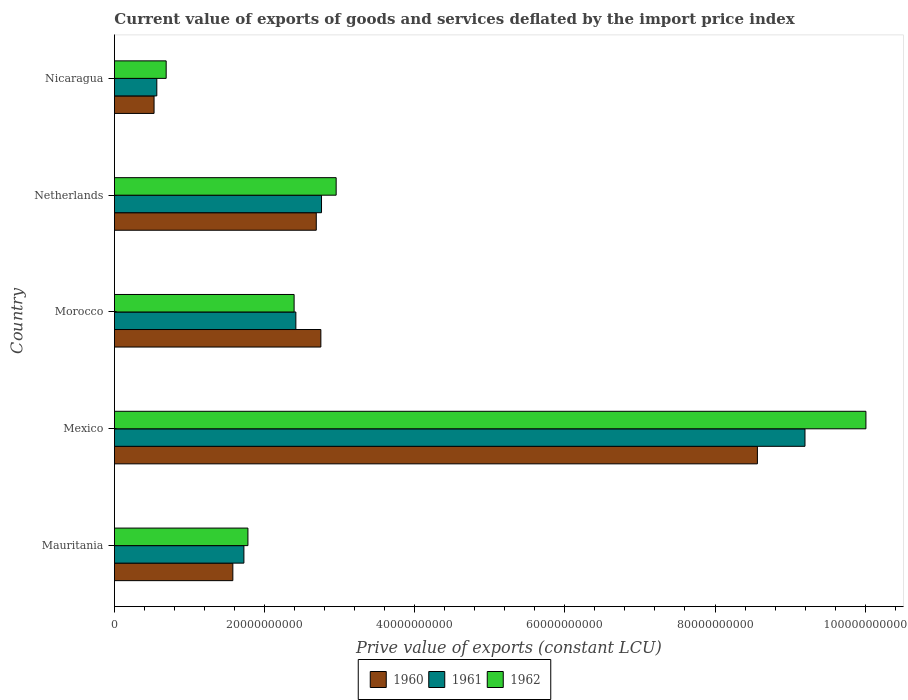Are the number of bars on each tick of the Y-axis equal?
Ensure brevity in your answer.  Yes. How many bars are there on the 2nd tick from the bottom?
Keep it short and to the point. 3. What is the label of the 5th group of bars from the top?
Ensure brevity in your answer.  Mauritania. In how many cases, is the number of bars for a given country not equal to the number of legend labels?
Give a very brief answer. 0. What is the prive value of exports in 1962 in Netherlands?
Offer a terse response. 2.95e+1. Across all countries, what is the maximum prive value of exports in 1961?
Your response must be concise. 9.20e+1. Across all countries, what is the minimum prive value of exports in 1962?
Your answer should be very brief. 6.89e+09. In which country was the prive value of exports in 1960 maximum?
Keep it short and to the point. Mexico. In which country was the prive value of exports in 1961 minimum?
Ensure brevity in your answer.  Nicaragua. What is the total prive value of exports in 1962 in the graph?
Provide a short and direct response. 1.78e+11. What is the difference between the prive value of exports in 1962 in Mexico and that in Netherlands?
Provide a succinct answer. 7.06e+1. What is the difference between the prive value of exports in 1960 in Netherlands and the prive value of exports in 1962 in Morocco?
Keep it short and to the point. 2.95e+09. What is the average prive value of exports in 1962 per country?
Give a very brief answer. 3.56e+1. What is the difference between the prive value of exports in 1960 and prive value of exports in 1961 in Netherlands?
Make the answer very short. -6.97e+08. What is the ratio of the prive value of exports in 1961 in Morocco to that in Netherlands?
Give a very brief answer. 0.88. Is the difference between the prive value of exports in 1960 in Morocco and Netherlands greater than the difference between the prive value of exports in 1961 in Morocco and Netherlands?
Ensure brevity in your answer.  Yes. What is the difference between the highest and the second highest prive value of exports in 1961?
Ensure brevity in your answer.  6.44e+1. What is the difference between the highest and the lowest prive value of exports in 1960?
Offer a very short reply. 8.04e+1. In how many countries, is the prive value of exports in 1962 greater than the average prive value of exports in 1962 taken over all countries?
Your answer should be very brief. 1. Is the sum of the prive value of exports in 1962 in Mauritania and Morocco greater than the maximum prive value of exports in 1961 across all countries?
Your answer should be very brief. No. What does the 1st bar from the bottom in Nicaragua represents?
Ensure brevity in your answer.  1960. Where does the legend appear in the graph?
Offer a terse response. Bottom center. How many legend labels are there?
Offer a terse response. 3. How are the legend labels stacked?
Offer a terse response. Horizontal. What is the title of the graph?
Provide a short and direct response. Current value of exports of goods and services deflated by the import price index. What is the label or title of the X-axis?
Provide a short and direct response. Prive value of exports (constant LCU). What is the label or title of the Y-axis?
Keep it short and to the point. Country. What is the Prive value of exports (constant LCU) of 1960 in Mauritania?
Your answer should be compact. 1.58e+1. What is the Prive value of exports (constant LCU) in 1961 in Mauritania?
Give a very brief answer. 1.72e+1. What is the Prive value of exports (constant LCU) in 1962 in Mauritania?
Your answer should be very brief. 1.78e+1. What is the Prive value of exports (constant LCU) of 1960 in Mexico?
Give a very brief answer. 8.56e+1. What is the Prive value of exports (constant LCU) of 1961 in Mexico?
Provide a short and direct response. 9.20e+1. What is the Prive value of exports (constant LCU) in 1962 in Mexico?
Provide a short and direct response. 1.00e+11. What is the Prive value of exports (constant LCU) of 1960 in Morocco?
Your answer should be very brief. 2.75e+1. What is the Prive value of exports (constant LCU) of 1961 in Morocco?
Provide a succinct answer. 2.42e+1. What is the Prive value of exports (constant LCU) in 1962 in Morocco?
Make the answer very short. 2.39e+1. What is the Prive value of exports (constant LCU) in 1960 in Netherlands?
Your response must be concise. 2.69e+1. What is the Prive value of exports (constant LCU) in 1961 in Netherlands?
Provide a succinct answer. 2.76e+1. What is the Prive value of exports (constant LCU) of 1962 in Netherlands?
Provide a succinct answer. 2.95e+1. What is the Prive value of exports (constant LCU) of 1960 in Nicaragua?
Offer a terse response. 5.28e+09. What is the Prive value of exports (constant LCU) of 1961 in Nicaragua?
Keep it short and to the point. 5.65e+09. What is the Prive value of exports (constant LCU) of 1962 in Nicaragua?
Keep it short and to the point. 6.89e+09. Across all countries, what is the maximum Prive value of exports (constant LCU) of 1960?
Provide a short and direct response. 8.56e+1. Across all countries, what is the maximum Prive value of exports (constant LCU) of 1961?
Your answer should be compact. 9.20e+1. Across all countries, what is the maximum Prive value of exports (constant LCU) in 1962?
Keep it short and to the point. 1.00e+11. Across all countries, what is the minimum Prive value of exports (constant LCU) in 1960?
Offer a very short reply. 5.28e+09. Across all countries, what is the minimum Prive value of exports (constant LCU) in 1961?
Make the answer very short. 5.65e+09. Across all countries, what is the minimum Prive value of exports (constant LCU) of 1962?
Offer a very short reply. 6.89e+09. What is the total Prive value of exports (constant LCU) in 1960 in the graph?
Your response must be concise. 1.61e+11. What is the total Prive value of exports (constant LCU) of 1961 in the graph?
Make the answer very short. 1.67e+11. What is the total Prive value of exports (constant LCU) in 1962 in the graph?
Offer a terse response. 1.78e+11. What is the difference between the Prive value of exports (constant LCU) in 1960 in Mauritania and that in Mexico?
Offer a terse response. -6.99e+1. What is the difference between the Prive value of exports (constant LCU) in 1961 in Mauritania and that in Mexico?
Keep it short and to the point. -7.47e+1. What is the difference between the Prive value of exports (constant LCU) in 1962 in Mauritania and that in Mexico?
Your response must be concise. -8.23e+1. What is the difference between the Prive value of exports (constant LCU) in 1960 in Mauritania and that in Morocco?
Keep it short and to the point. -1.17e+1. What is the difference between the Prive value of exports (constant LCU) in 1961 in Mauritania and that in Morocco?
Your response must be concise. -6.92e+09. What is the difference between the Prive value of exports (constant LCU) of 1962 in Mauritania and that in Morocco?
Provide a short and direct response. -6.15e+09. What is the difference between the Prive value of exports (constant LCU) in 1960 in Mauritania and that in Netherlands?
Offer a terse response. -1.11e+1. What is the difference between the Prive value of exports (constant LCU) of 1961 in Mauritania and that in Netherlands?
Give a very brief answer. -1.03e+1. What is the difference between the Prive value of exports (constant LCU) of 1962 in Mauritania and that in Netherlands?
Ensure brevity in your answer.  -1.18e+1. What is the difference between the Prive value of exports (constant LCU) in 1960 in Mauritania and that in Nicaragua?
Your answer should be very brief. 1.05e+1. What is the difference between the Prive value of exports (constant LCU) of 1961 in Mauritania and that in Nicaragua?
Give a very brief answer. 1.16e+1. What is the difference between the Prive value of exports (constant LCU) in 1962 in Mauritania and that in Nicaragua?
Offer a terse response. 1.09e+1. What is the difference between the Prive value of exports (constant LCU) of 1960 in Mexico and that in Morocco?
Ensure brevity in your answer.  5.82e+1. What is the difference between the Prive value of exports (constant LCU) in 1961 in Mexico and that in Morocco?
Your response must be concise. 6.78e+1. What is the difference between the Prive value of exports (constant LCU) of 1962 in Mexico and that in Morocco?
Offer a very short reply. 7.62e+1. What is the difference between the Prive value of exports (constant LCU) of 1960 in Mexico and that in Netherlands?
Your answer should be compact. 5.88e+1. What is the difference between the Prive value of exports (constant LCU) in 1961 in Mexico and that in Netherlands?
Keep it short and to the point. 6.44e+1. What is the difference between the Prive value of exports (constant LCU) in 1962 in Mexico and that in Netherlands?
Your answer should be compact. 7.06e+1. What is the difference between the Prive value of exports (constant LCU) of 1960 in Mexico and that in Nicaragua?
Offer a terse response. 8.04e+1. What is the difference between the Prive value of exports (constant LCU) in 1961 in Mexico and that in Nicaragua?
Ensure brevity in your answer.  8.63e+1. What is the difference between the Prive value of exports (constant LCU) of 1962 in Mexico and that in Nicaragua?
Provide a succinct answer. 9.32e+1. What is the difference between the Prive value of exports (constant LCU) in 1960 in Morocco and that in Netherlands?
Ensure brevity in your answer.  6.10e+08. What is the difference between the Prive value of exports (constant LCU) in 1961 in Morocco and that in Netherlands?
Offer a very short reply. -3.42e+09. What is the difference between the Prive value of exports (constant LCU) in 1962 in Morocco and that in Netherlands?
Give a very brief answer. -5.60e+09. What is the difference between the Prive value of exports (constant LCU) in 1960 in Morocco and that in Nicaragua?
Provide a succinct answer. 2.22e+1. What is the difference between the Prive value of exports (constant LCU) of 1961 in Morocco and that in Nicaragua?
Provide a succinct answer. 1.85e+1. What is the difference between the Prive value of exports (constant LCU) of 1962 in Morocco and that in Nicaragua?
Keep it short and to the point. 1.70e+1. What is the difference between the Prive value of exports (constant LCU) in 1960 in Netherlands and that in Nicaragua?
Your answer should be very brief. 2.16e+1. What is the difference between the Prive value of exports (constant LCU) in 1961 in Netherlands and that in Nicaragua?
Keep it short and to the point. 2.19e+1. What is the difference between the Prive value of exports (constant LCU) in 1962 in Netherlands and that in Nicaragua?
Your response must be concise. 2.26e+1. What is the difference between the Prive value of exports (constant LCU) in 1960 in Mauritania and the Prive value of exports (constant LCU) in 1961 in Mexico?
Your answer should be very brief. -7.62e+1. What is the difference between the Prive value of exports (constant LCU) of 1960 in Mauritania and the Prive value of exports (constant LCU) of 1962 in Mexico?
Your answer should be compact. -8.43e+1. What is the difference between the Prive value of exports (constant LCU) in 1961 in Mauritania and the Prive value of exports (constant LCU) in 1962 in Mexico?
Give a very brief answer. -8.29e+1. What is the difference between the Prive value of exports (constant LCU) of 1960 in Mauritania and the Prive value of exports (constant LCU) of 1961 in Morocco?
Give a very brief answer. -8.39e+09. What is the difference between the Prive value of exports (constant LCU) in 1960 in Mauritania and the Prive value of exports (constant LCU) in 1962 in Morocco?
Your answer should be very brief. -8.16e+09. What is the difference between the Prive value of exports (constant LCU) of 1961 in Mauritania and the Prive value of exports (constant LCU) of 1962 in Morocco?
Ensure brevity in your answer.  -6.69e+09. What is the difference between the Prive value of exports (constant LCU) in 1960 in Mauritania and the Prive value of exports (constant LCU) in 1961 in Netherlands?
Make the answer very short. -1.18e+1. What is the difference between the Prive value of exports (constant LCU) in 1960 in Mauritania and the Prive value of exports (constant LCU) in 1962 in Netherlands?
Ensure brevity in your answer.  -1.38e+1. What is the difference between the Prive value of exports (constant LCU) of 1961 in Mauritania and the Prive value of exports (constant LCU) of 1962 in Netherlands?
Offer a very short reply. -1.23e+1. What is the difference between the Prive value of exports (constant LCU) in 1960 in Mauritania and the Prive value of exports (constant LCU) in 1961 in Nicaragua?
Your answer should be very brief. 1.01e+1. What is the difference between the Prive value of exports (constant LCU) of 1960 in Mauritania and the Prive value of exports (constant LCU) of 1962 in Nicaragua?
Your answer should be compact. 8.88e+09. What is the difference between the Prive value of exports (constant LCU) of 1961 in Mauritania and the Prive value of exports (constant LCU) of 1962 in Nicaragua?
Provide a short and direct response. 1.04e+1. What is the difference between the Prive value of exports (constant LCU) of 1960 in Mexico and the Prive value of exports (constant LCU) of 1961 in Morocco?
Ensure brevity in your answer.  6.15e+1. What is the difference between the Prive value of exports (constant LCU) of 1960 in Mexico and the Prive value of exports (constant LCU) of 1962 in Morocco?
Offer a terse response. 6.17e+1. What is the difference between the Prive value of exports (constant LCU) of 1961 in Mexico and the Prive value of exports (constant LCU) of 1962 in Morocco?
Make the answer very short. 6.81e+1. What is the difference between the Prive value of exports (constant LCU) of 1960 in Mexico and the Prive value of exports (constant LCU) of 1961 in Netherlands?
Your answer should be compact. 5.81e+1. What is the difference between the Prive value of exports (constant LCU) in 1960 in Mexico and the Prive value of exports (constant LCU) in 1962 in Netherlands?
Your response must be concise. 5.61e+1. What is the difference between the Prive value of exports (constant LCU) in 1961 in Mexico and the Prive value of exports (constant LCU) in 1962 in Netherlands?
Offer a very short reply. 6.24e+1. What is the difference between the Prive value of exports (constant LCU) in 1960 in Mexico and the Prive value of exports (constant LCU) in 1961 in Nicaragua?
Your response must be concise. 8.00e+1. What is the difference between the Prive value of exports (constant LCU) of 1960 in Mexico and the Prive value of exports (constant LCU) of 1962 in Nicaragua?
Make the answer very short. 7.88e+1. What is the difference between the Prive value of exports (constant LCU) of 1961 in Mexico and the Prive value of exports (constant LCU) of 1962 in Nicaragua?
Offer a terse response. 8.51e+1. What is the difference between the Prive value of exports (constant LCU) in 1960 in Morocco and the Prive value of exports (constant LCU) in 1961 in Netherlands?
Offer a terse response. -8.70e+07. What is the difference between the Prive value of exports (constant LCU) in 1960 in Morocco and the Prive value of exports (constant LCU) in 1962 in Netherlands?
Offer a terse response. -2.04e+09. What is the difference between the Prive value of exports (constant LCU) of 1961 in Morocco and the Prive value of exports (constant LCU) of 1962 in Netherlands?
Provide a succinct answer. -5.37e+09. What is the difference between the Prive value of exports (constant LCU) of 1960 in Morocco and the Prive value of exports (constant LCU) of 1961 in Nicaragua?
Provide a short and direct response. 2.19e+1. What is the difference between the Prive value of exports (constant LCU) in 1960 in Morocco and the Prive value of exports (constant LCU) in 1962 in Nicaragua?
Your answer should be compact. 2.06e+1. What is the difference between the Prive value of exports (constant LCU) in 1961 in Morocco and the Prive value of exports (constant LCU) in 1962 in Nicaragua?
Offer a very short reply. 1.73e+1. What is the difference between the Prive value of exports (constant LCU) of 1960 in Netherlands and the Prive value of exports (constant LCU) of 1961 in Nicaragua?
Your answer should be very brief. 2.12e+1. What is the difference between the Prive value of exports (constant LCU) in 1960 in Netherlands and the Prive value of exports (constant LCU) in 1962 in Nicaragua?
Offer a terse response. 2.00e+1. What is the difference between the Prive value of exports (constant LCU) of 1961 in Netherlands and the Prive value of exports (constant LCU) of 1962 in Nicaragua?
Provide a succinct answer. 2.07e+1. What is the average Prive value of exports (constant LCU) in 1960 per country?
Provide a short and direct response. 3.22e+1. What is the average Prive value of exports (constant LCU) in 1961 per country?
Provide a short and direct response. 3.33e+1. What is the average Prive value of exports (constant LCU) of 1962 per country?
Your response must be concise. 3.56e+1. What is the difference between the Prive value of exports (constant LCU) in 1960 and Prive value of exports (constant LCU) in 1961 in Mauritania?
Offer a terse response. -1.47e+09. What is the difference between the Prive value of exports (constant LCU) in 1960 and Prive value of exports (constant LCU) in 1962 in Mauritania?
Make the answer very short. -2.01e+09. What is the difference between the Prive value of exports (constant LCU) in 1961 and Prive value of exports (constant LCU) in 1962 in Mauritania?
Keep it short and to the point. -5.35e+08. What is the difference between the Prive value of exports (constant LCU) of 1960 and Prive value of exports (constant LCU) of 1961 in Mexico?
Provide a succinct answer. -6.34e+09. What is the difference between the Prive value of exports (constant LCU) of 1960 and Prive value of exports (constant LCU) of 1962 in Mexico?
Ensure brevity in your answer.  -1.45e+1. What is the difference between the Prive value of exports (constant LCU) in 1961 and Prive value of exports (constant LCU) in 1962 in Mexico?
Offer a terse response. -8.12e+09. What is the difference between the Prive value of exports (constant LCU) in 1960 and Prive value of exports (constant LCU) in 1961 in Morocco?
Offer a very short reply. 3.33e+09. What is the difference between the Prive value of exports (constant LCU) of 1960 and Prive value of exports (constant LCU) of 1962 in Morocco?
Offer a very short reply. 3.56e+09. What is the difference between the Prive value of exports (constant LCU) of 1961 and Prive value of exports (constant LCU) of 1962 in Morocco?
Ensure brevity in your answer.  2.33e+08. What is the difference between the Prive value of exports (constant LCU) in 1960 and Prive value of exports (constant LCU) in 1961 in Netherlands?
Ensure brevity in your answer.  -6.97e+08. What is the difference between the Prive value of exports (constant LCU) in 1960 and Prive value of exports (constant LCU) in 1962 in Netherlands?
Your answer should be very brief. -2.65e+09. What is the difference between the Prive value of exports (constant LCU) of 1961 and Prive value of exports (constant LCU) of 1962 in Netherlands?
Offer a very short reply. -1.95e+09. What is the difference between the Prive value of exports (constant LCU) in 1960 and Prive value of exports (constant LCU) in 1961 in Nicaragua?
Provide a succinct answer. -3.67e+08. What is the difference between the Prive value of exports (constant LCU) of 1960 and Prive value of exports (constant LCU) of 1962 in Nicaragua?
Your answer should be compact. -1.61e+09. What is the difference between the Prive value of exports (constant LCU) of 1961 and Prive value of exports (constant LCU) of 1962 in Nicaragua?
Your response must be concise. -1.25e+09. What is the ratio of the Prive value of exports (constant LCU) in 1960 in Mauritania to that in Mexico?
Your answer should be compact. 0.18. What is the ratio of the Prive value of exports (constant LCU) of 1961 in Mauritania to that in Mexico?
Keep it short and to the point. 0.19. What is the ratio of the Prive value of exports (constant LCU) in 1962 in Mauritania to that in Mexico?
Your answer should be compact. 0.18. What is the ratio of the Prive value of exports (constant LCU) of 1960 in Mauritania to that in Morocco?
Give a very brief answer. 0.57. What is the ratio of the Prive value of exports (constant LCU) in 1961 in Mauritania to that in Morocco?
Make the answer very short. 0.71. What is the ratio of the Prive value of exports (constant LCU) in 1962 in Mauritania to that in Morocco?
Your answer should be compact. 0.74. What is the ratio of the Prive value of exports (constant LCU) in 1960 in Mauritania to that in Netherlands?
Make the answer very short. 0.59. What is the ratio of the Prive value of exports (constant LCU) of 1961 in Mauritania to that in Netherlands?
Your answer should be very brief. 0.63. What is the ratio of the Prive value of exports (constant LCU) of 1962 in Mauritania to that in Netherlands?
Give a very brief answer. 0.6. What is the ratio of the Prive value of exports (constant LCU) in 1960 in Mauritania to that in Nicaragua?
Provide a succinct answer. 2.99. What is the ratio of the Prive value of exports (constant LCU) of 1961 in Mauritania to that in Nicaragua?
Ensure brevity in your answer.  3.05. What is the ratio of the Prive value of exports (constant LCU) of 1962 in Mauritania to that in Nicaragua?
Your answer should be very brief. 2.58. What is the ratio of the Prive value of exports (constant LCU) of 1960 in Mexico to that in Morocco?
Ensure brevity in your answer.  3.11. What is the ratio of the Prive value of exports (constant LCU) of 1961 in Mexico to that in Morocco?
Offer a very short reply. 3.81. What is the ratio of the Prive value of exports (constant LCU) of 1962 in Mexico to that in Morocco?
Your answer should be compact. 4.18. What is the ratio of the Prive value of exports (constant LCU) in 1960 in Mexico to that in Netherlands?
Provide a short and direct response. 3.19. What is the ratio of the Prive value of exports (constant LCU) in 1961 in Mexico to that in Netherlands?
Your answer should be very brief. 3.33. What is the ratio of the Prive value of exports (constant LCU) in 1962 in Mexico to that in Netherlands?
Keep it short and to the point. 3.39. What is the ratio of the Prive value of exports (constant LCU) of 1960 in Mexico to that in Nicaragua?
Your answer should be compact. 16.22. What is the ratio of the Prive value of exports (constant LCU) in 1961 in Mexico to that in Nicaragua?
Ensure brevity in your answer.  16.29. What is the ratio of the Prive value of exports (constant LCU) of 1962 in Mexico to that in Nicaragua?
Keep it short and to the point. 14.52. What is the ratio of the Prive value of exports (constant LCU) of 1960 in Morocco to that in Netherlands?
Provide a short and direct response. 1.02. What is the ratio of the Prive value of exports (constant LCU) in 1961 in Morocco to that in Netherlands?
Your answer should be very brief. 0.88. What is the ratio of the Prive value of exports (constant LCU) in 1962 in Morocco to that in Netherlands?
Provide a short and direct response. 0.81. What is the ratio of the Prive value of exports (constant LCU) of 1960 in Morocco to that in Nicaragua?
Ensure brevity in your answer.  5.21. What is the ratio of the Prive value of exports (constant LCU) of 1961 in Morocco to that in Nicaragua?
Offer a terse response. 4.28. What is the ratio of the Prive value of exports (constant LCU) of 1962 in Morocco to that in Nicaragua?
Offer a very short reply. 3.47. What is the ratio of the Prive value of exports (constant LCU) in 1960 in Netherlands to that in Nicaragua?
Make the answer very short. 5.09. What is the ratio of the Prive value of exports (constant LCU) in 1961 in Netherlands to that in Nicaragua?
Your answer should be very brief. 4.89. What is the ratio of the Prive value of exports (constant LCU) in 1962 in Netherlands to that in Nicaragua?
Your answer should be very brief. 4.29. What is the difference between the highest and the second highest Prive value of exports (constant LCU) in 1960?
Provide a succinct answer. 5.82e+1. What is the difference between the highest and the second highest Prive value of exports (constant LCU) in 1961?
Offer a very short reply. 6.44e+1. What is the difference between the highest and the second highest Prive value of exports (constant LCU) of 1962?
Provide a short and direct response. 7.06e+1. What is the difference between the highest and the lowest Prive value of exports (constant LCU) in 1960?
Offer a very short reply. 8.04e+1. What is the difference between the highest and the lowest Prive value of exports (constant LCU) in 1961?
Your response must be concise. 8.63e+1. What is the difference between the highest and the lowest Prive value of exports (constant LCU) in 1962?
Offer a very short reply. 9.32e+1. 